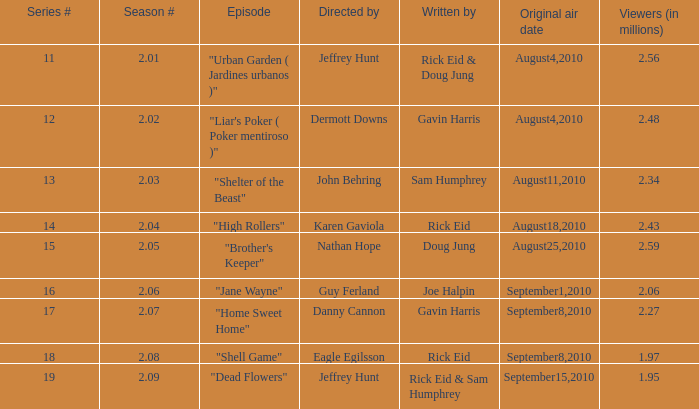What is the number of viewers when the series is at episode 14? 2.43. 